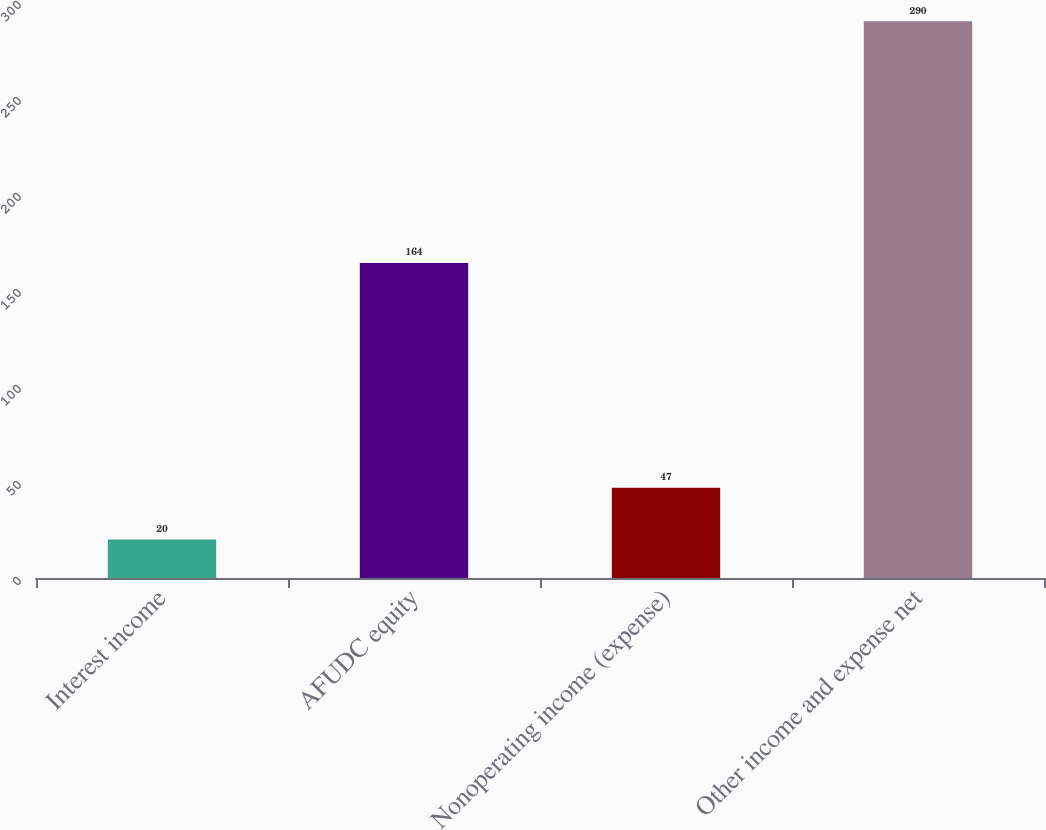Convert chart to OTSL. <chart><loc_0><loc_0><loc_500><loc_500><bar_chart><fcel>Interest income<fcel>AFUDC equity<fcel>Nonoperating income (expense)<fcel>Other income and expense net<nl><fcel>20<fcel>164<fcel>47<fcel>290<nl></chart> 